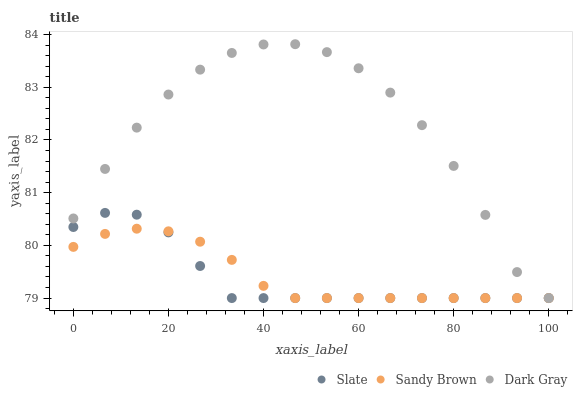Does Slate have the minimum area under the curve?
Answer yes or no. Yes. Does Dark Gray have the maximum area under the curve?
Answer yes or no. Yes. Does Sandy Brown have the minimum area under the curve?
Answer yes or no. No. Does Sandy Brown have the maximum area under the curve?
Answer yes or no. No. Is Sandy Brown the smoothest?
Answer yes or no. Yes. Is Dark Gray the roughest?
Answer yes or no. Yes. Is Slate the smoothest?
Answer yes or no. No. Is Slate the roughest?
Answer yes or no. No. Does Dark Gray have the lowest value?
Answer yes or no. Yes. Does Dark Gray have the highest value?
Answer yes or no. Yes. Does Slate have the highest value?
Answer yes or no. No. Does Sandy Brown intersect Slate?
Answer yes or no. Yes. Is Sandy Brown less than Slate?
Answer yes or no. No. Is Sandy Brown greater than Slate?
Answer yes or no. No. 